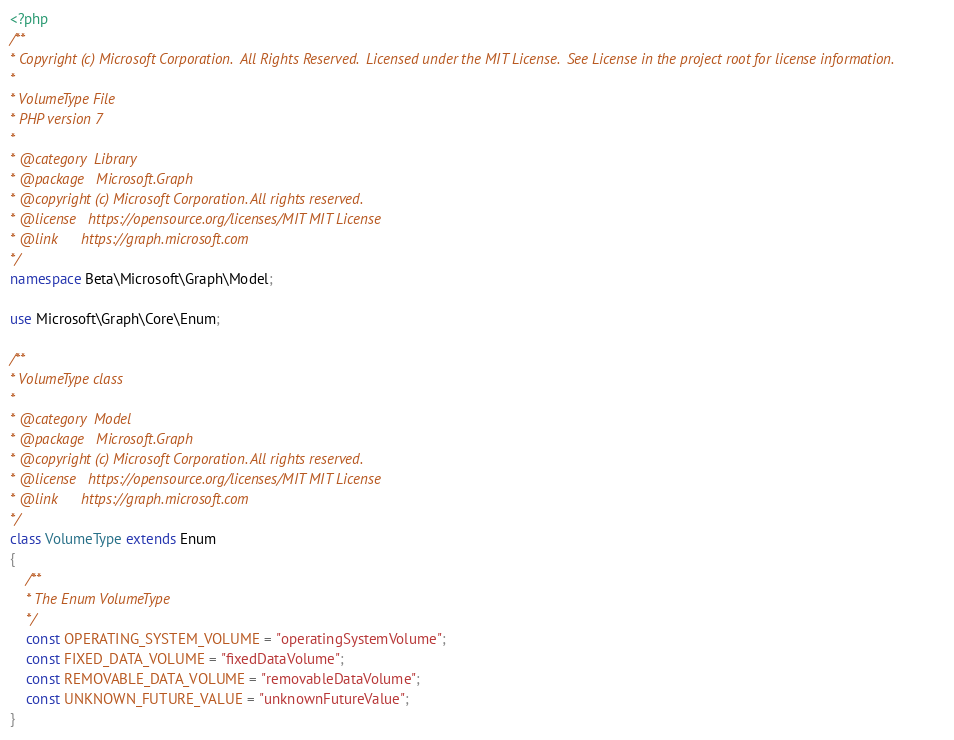<code> <loc_0><loc_0><loc_500><loc_500><_PHP_><?php
/**
* Copyright (c) Microsoft Corporation.  All Rights Reserved.  Licensed under the MIT License.  See License in the project root for license information.
* 
* VolumeType File
* PHP version 7
*
* @category  Library
* @package   Microsoft.Graph
* @copyright (c) Microsoft Corporation. All rights reserved.
* @license   https://opensource.org/licenses/MIT MIT License
* @link      https://graph.microsoft.com
*/
namespace Beta\Microsoft\Graph\Model;

use Microsoft\Graph\Core\Enum;

/**
* VolumeType class
*
* @category  Model
* @package   Microsoft.Graph
* @copyright (c) Microsoft Corporation. All rights reserved.
* @license   https://opensource.org/licenses/MIT MIT License
* @link      https://graph.microsoft.com
*/
class VolumeType extends Enum
{
    /**
    * The Enum VolumeType
    */
    const OPERATING_SYSTEM_VOLUME = "operatingSystemVolume";
    const FIXED_DATA_VOLUME = "fixedDataVolume";
    const REMOVABLE_DATA_VOLUME = "removableDataVolume";
    const UNKNOWN_FUTURE_VALUE = "unknownFutureValue";
}</code> 